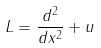<formula> <loc_0><loc_0><loc_500><loc_500>L = \frac { d ^ { 2 } } { d x ^ { 2 } } + u</formula> 